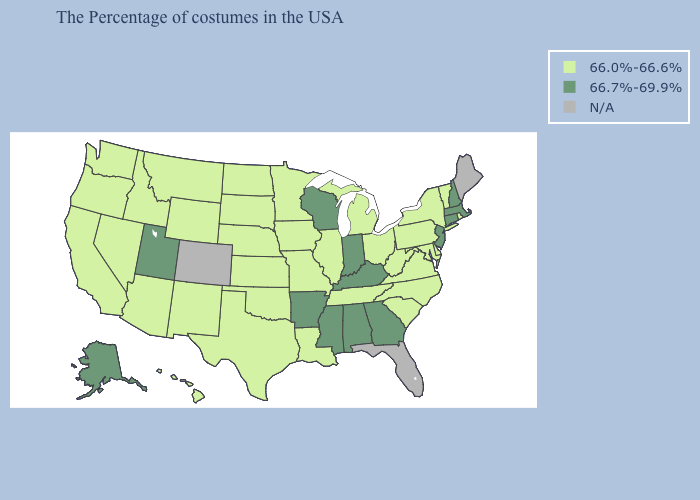Does Pennsylvania have the highest value in the Northeast?
Write a very short answer. No. Which states have the highest value in the USA?
Short answer required. Massachusetts, New Hampshire, Connecticut, New Jersey, Georgia, Kentucky, Indiana, Alabama, Wisconsin, Mississippi, Arkansas, Utah, Alaska. Among the states that border Louisiana , which have the highest value?
Give a very brief answer. Mississippi, Arkansas. What is the highest value in the USA?
Quick response, please. 66.7%-69.9%. What is the value of Mississippi?
Quick response, please. 66.7%-69.9%. What is the value of South Carolina?
Keep it brief. 66.0%-66.6%. What is the value of Arizona?
Answer briefly. 66.0%-66.6%. Does the first symbol in the legend represent the smallest category?
Give a very brief answer. Yes. Which states have the highest value in the USA?
Answer briefly. Massachusetts, New Hampshire, Connecticut, New Jersey, Georgia, Kentucky, Indiana, Alabama, Wisconsin, Mississippi, Arkansas, Utah, Alaska. Among the states that border Kentucky , does Indiana have the lowest value?
Short answer required. No. Does Mississippi have the lowest value in the South?
Keep it brief. No. Name the states that have a value in the range 66.0%-66.6%?
Answer briefly. Rhode Island, Vermont, New York, Delaware, Maryland, Pennsylvania, Virginia, North Carolina, South Carolina, West Virginia, Ohio, Michigan, Tennessee, Illinois, Louisiana, Missouri, Minnesota, Iowa, Kansas, Nebraska, Oklahoma, Texas, South Dakota, North Dakota, Wyoming, New Mexico, Montana, Arizona, Idaho, Nevada, California, Washington, Oregon, Hawaii. Name the states that have a value in the range 66.0%-66.6%?
Be succinct. Rhode Island, Vermont, New York, Delaware, Maryland, Pennsylvania, Virginia, North Carolina, South Carolina, West Virginia, Ohio, Michigan, Tennessee, Illinois, Louisiana, Missouri, Minnesota, Iowa, Kansas, Nebraska, Oklahoma, Texas, South Dakota, North Dakota, Wyoming, New Mexico, Montana, Arizona, Idaho, Nevada, California, Washington, Oregon, Hawaii. What is the value of Hawaii?
Keep it brief. 66.0%-66.6%. What is the highest value in states that border Minnesota?
Keep it brief. 66.7%-69.9%. 